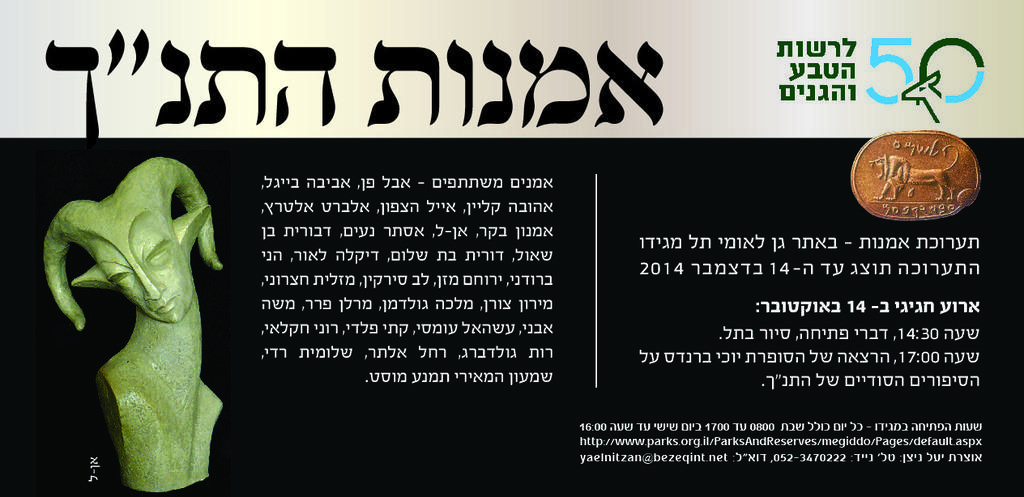How would you summarize this image in a sentence or two? In this image, we can see a poster. On this poster, we can see text, sculpture and coin. 